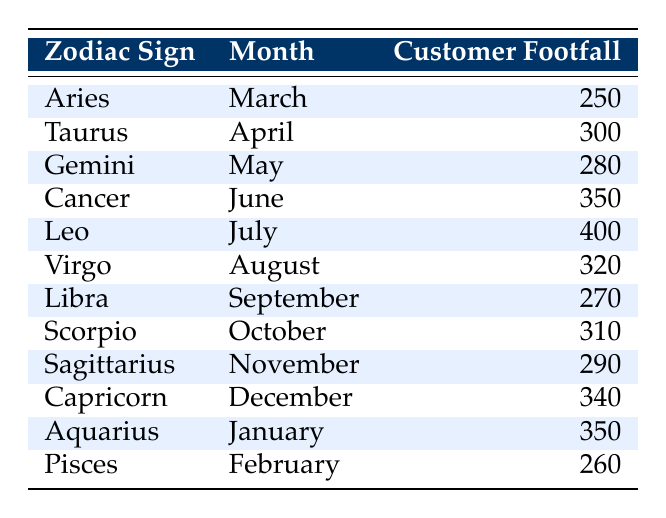What is the customer footfall for Leo? According to the table, Leo corresponds to the month of July. The customer footfall entry for Leo in July is 400.
Answer: 400 Which zodiac sign has the highest customer footfall? By reviewing the customer footfall numbers for all zodiac signs, Leo has the highest footfall at 400.
Answer: Leo What is the average customer footfall from Cancer to Capricorn? First, identify customer footfall values from Cancer (350) through Capricorn (340). The sum of these values is 350 + 400 + 320 + 270 + 310 + 290 + 340 = 2270. There are 7 zodiac signs, so the average is 2270 / 7 ≈ 324.29.
Answer: Approximately 324.29 Is customer footfall higher in April than in March? The customer footfall for Taurus in April is 300, while for Aries in March it is 250. Since 300 is greater than 250, the answer is yes.
Answer: Yes Which month has the lowest customer footfall? The entries for customer footfall are as follows: March (250), April (300), May (280), June (350), July (400), August (320), September (270), October (310), November (290), December (340), January (350), and February (260). The lowest value is 250 in March.
Answer: March What is the total customer footfall from January to April? The customer footfall values to include are for Aquarius in January (350), Pisces in February (260), Aries in March (250), and Taurus in April (300). Adding them gives 350 + 260 + 250 + 300 = 1160.
Answer: 1160 Is the customer footfall for Sagittarius greater than that for Gemini? The customer footfall for Sagittarius in November is 290, while for Gemini in May it is 280. Since 290 is greater than 280, the answer is yes.
Answer: Yes What is the difference in customer footfall between July and September? The customer footfall for Leo in July is 400, and for Libra in September, it is 270. The difference is calculated as 400 - 270 = 130.
Answer: 130 What zodiac sign is associated with the month that has a footfall of 340? The customer footfall of 340 is associated with Capricorn, which corresponds to December.
Answer: Capricorn 